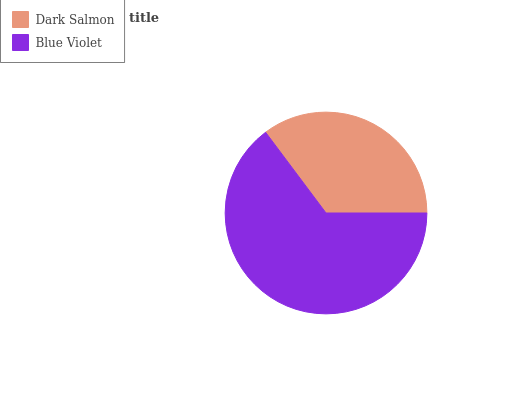Is Dark Salmon the minimum?
Answer yes or no. Yes. Is Blue Violet the maximum?
Answer yes or no. Yes. Is Blue Violet the minimum?
Answer yes or no. No. Is Blue Violet greater than Dark Salmon?
Answer yes or no. Yes. Is Dark Salmon less than Blue Violet?
Answer yes or no. Yes. Is Dark Salmon greater than Blue Violet?
Answer yes or no. No. Is Blue Violet less than Dark Salmon?
Answer yes or no. No. Is Blue Violet the high median?
Answer yes or no. Yes. Is Dark Salmon the low median?
Answer yes or no. Yes. Is Dark Salmon the high median?
Answer yes or no. No. Is Blue Violet the low median?
Answer yes or no. No. 